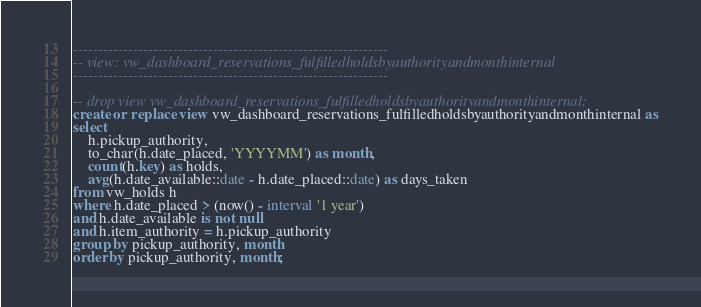Convert code to text. <code><loc_0><loc_0><loc_500><loc_500><_SQL_>---------------------------------------------------------------
-- view: vw_dashboard_reservations_fulfilledholdsbyauthorityandmonthinternal
---------------------------------------------------------------

-- drop view vw_dashboard_reservations_fulfilledholdsbyauthorityandmonthinternal;
create or replace view vw_dashboard_reservations_fulfilledholdsbyauthorityandmonthinternal as
select
    h.pickup_authority,
    to_char(h.date_placed, 'YYYYMM') as month,
    count(h.key) as holds,
    avg(h.date_available::date - h.date_placed::date) as days_taken
from vw_holds h
where h.date_placed > (now() - interval '1 year')
and h.date_available is not null
and h.item_authority = h.pickup_authority
group by pickup_authority, month
order by pickup_authority, month;</code> 